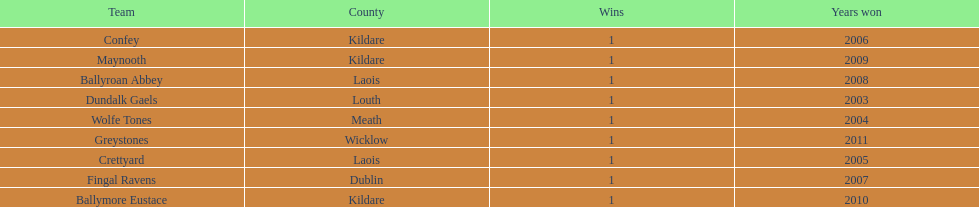What is the total of wins on the chart 9. 